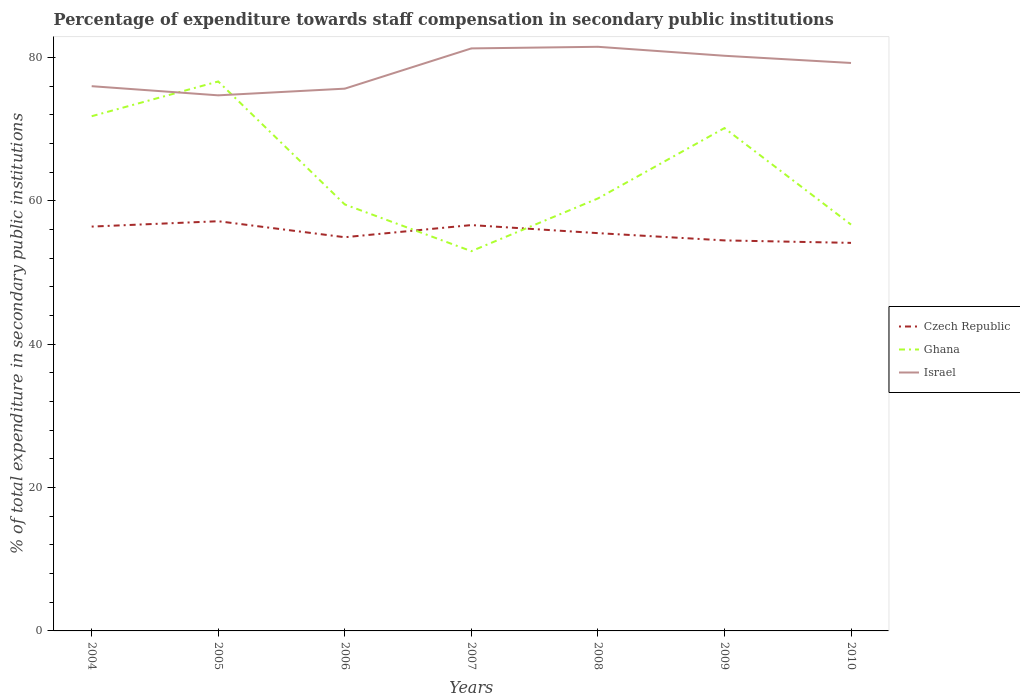How many different coloured lines are there?
Give a very brief answer. 3. Does the line corresponding to Israel intersect with the line corresponding to Czech Republic?
Provide a short and direct response. No. Is the number of lines equal to the number of legend labels?
Keep it short and to the point. Yes. Across all years, what is the maximum percentage of expenditure towards staff compensation in Israel?
Provide a succinct answer. 74.7. What is the total percentage of expenditure towards staff compensation in Czech Republic in the graph?
Provide a succinct answer. 2.27. What is the difference between the highest and the second highest percentage of expenditure towards staff compensation in Israel?
Your response must be concise. 6.77. What is the difference between the highest and the lowest percentage of expenditure towards staff compensation in Czech Republic?
Keep it short and to the point. 3. Is the percentage of expenditure towards staff compensation in Israel strictly greater than the percentage of expenditure towards staff compensation in Czech Republic over the years?
Offer a very short reply. No. Does the graph contain grids?
Your answer should be very brief. No. Where does the legend appear in the graph?
Give a very brief answer. Center right. How many legend labels are there?
Keep it short and to the point. 3. How are the legend labels stacked?
Make the answer very short. Vertical. What is the title of the graph?
Provide a succinct answer. Percentage of expenditure towards staff compensation in secondary public institutions. Does "Tonga" appear as one of the legend labels in the graph?
Your answer should be compact. No. What is the label or title of the X-axis?
Make the answer very short. Years. What is the label or title of the Y-axis?
Give a very brief answer. % of total expenditure in secondary public institutions. What is the % of total expenditure in secondary public institutions of Czech Republic in 2004?
Give a very brief answer. 56.39. What is the % of total expenditure in secondary public institutions in Ghana in 2004?
Offer a very short reply. 71.79. What is the % of total expenditure in secondary public institutions of Israel in 2004?
Your answer should be compact. 75.97. What is the % of total expenditure in secondary public institutions in Czech Republic in 2005?
Your answer should be compact. 57.14. What is the % of total expenditure in secondary public institutions in Ghana in 2005?
Make the answer very short. 76.63. What is the % of total expenditure in secondary public institutions of Israel in 2005?
Offer a terse response. 74.7. What is the % of total expenditure in secondary public institutions in Czech Republic in 2006?
Offer a very short reply. 54.91. What is the % of total expenditure in secondary public institutions of Ghana in 2006?
Your answer should be compact. 59.48. What is the % of total expenditure in secondary public institutions in Israel in 2006?
Provide a succinct answer. 75.63. What is the % of total expenditure in secondary public institutions in Czech Republic in 2007?
Give a very brief answer. 56.6. What is the % of total expenditure in secondary public institutions in Ghana in 2007?
Offer a very short reply. 52.97. What is the % of total expenditure in secondary public institutions in Israel in 2007?
Give a very brief answer. 81.24. What is the % of total expenditure in secondary public institutions of Czech Republic in 2008?
Your answer should be compact. 55.48. What is the % of total expenditure in secondary public institutions of Ghana in 2008?
Your answer should be compact. 60.31. What is the % of total expenditure in secondary public institutions in Israel in 2008?
Offer a very short reply. 81.47. What is the % of total expenditure in secondary public institutions in Czech Republic in 2009?
Your answer should be very brief. 54.46. What is the % of total expenditure in secondary public institutions in Ghana in 2009?
Give a very brief answer. 70.13. What is the % of total expenditure in secondary public institutions of Israel in 2009?
Your answer should be very brief. 80.22. What is the % of total expenditure in secondary public institutions of Czech Republic in 2010?
Offer a terse response. 54.12. What is the % of total expenditure in secondary public institutions in Ghana in 2010?
Make the answer very short. 56.67. What is the % of total expenditure in secondary public institutions in Israel in 2010?
Your answer should be compact. 79.21. Across all years, what is the maximum % of total expenditure in secondary public institutions in Czech Republic?
Your response must be concise. 57.14. Across all years, what is the maximum % of total expenditure in secondary public institutions of Ghana?
Provide a short and direct response. 76.63. Across all years, what is the maximum % of total expenditure in secondary public institutions in Israel?
Provide a succinct answer. 81.47. Across all years, what is the minimum % of total expenditure in secondary public institutions of Czech Republic?
Ensure brevity in your answer.  54.12. Across all years, what is the minimum % of total expenditure in secondary public institutions of Ghana?
Provide a short and direct response. 52.97. Across all years, what is the minimum % of total expenditure in secondary public institutions in Israel?
Your answer should be compact. 74.7. What is the total % of total expenditure in secondary public institutions of Czech Republic in the graph?
Make the answer very short. 389.11. What is the total % of total expenditure in secondary public institutions in Ghana in the graph?
Your answer should be very brief. 447.98. What is the total % of total expenditure in secondary public institutions of Israel in the graph?
Provide a short and direct response. 548.44. What is the difference between the % of total expenditure in secondary public institutions in Czech Republic in 2004 and that in 2005?
Your answer should be very brief. -0.75. What is the difference between the % of total expenditure in secondary public institutions of Ghana in 2004 and that in 2005?
Keep it short and to the point. -4.85. What is the difference between the % of total expenditure in secondary public institutions of Israel in 2004 and that in 2005?
Ensure brevity in your answer.  1.28. What is the difference between the % of total expenditure in secondary public institutions of Czech Republic in 2004 and that in 2006?
Make the answer very short. 1.48. What is the difference between the % of total expenditure in secondary public institutions in Ghana in 2004 and that in 2006?
Give a very brief answer. 12.31. What is the difference between the % of total expenditure in secondary public institutions of Israel in 2004 and that in 2006?
Give a very brief answer. 0.35. What is the difference between the % of total expenditure in secondary public institutions of Czech Republic in 2004 and that in 2007?
Ensure brevity in your answer.  -0.21. What is the difference between the % of total expenditure in secondary public institutions of Ghana in 2004 and that in 2007?
Ensure brevity in your answer.  18.82. What is the difference between the % of total expenditure in secondary public institutions in Israel in 2004 and that in 2007?
Offer a very short reply. -5.27. What is the difference between the % of total expenditure in secondary public institutions in Czech Republic in 2004 and that in 2008?
Give a very brief answer. 0.91. What is the difference between the % of total expenditure in secondary public institutions of Ghana in 2004 and that in 2008?
Your response must be concise. 11.47. What is the difference between the % of total expenditure in secondary public institutions in Israel in 2004 and that in 2008?
Offer a terse response. -5.49. What is the difference between the % of total expenditure in secondary public institutions of Czech Republic in 2004 and that in 2009?
Make the answer very short. 1.93. What is the difference between the % of total expenditure in secondary public institutions in Ghana in 2004 and that in 2009?
Offer a terse response. 1.65. What is the difference between the % of total expenditure in secondary public institutions of Israel in 2004 and that in 2009?
Provide a succinct answer. -4.24. What is the difference between the % of total expenditure in secondary public institutions of Czech Republic in 2004 and that in 2010?
Give a very brief answer. 2.27. What is the difference between the % of total expenditure in secondary public institutions in Ghana in 2004 and that in 2010?
Ensure brevity in your answer.  15.11. What is the difference between the % of total expenditure in secondary public institutions in Israel in 2004 and that in 2010?
Provide a short and direct response. -3.24. What is the difference between the % of total expenditure in secondary public institutions of Czech Republic in 2005 and that in 2006?
Offer a very short reply. 2.23. What is the difference between the % of total expenditure in secondary public institutions in Ghana in 2005 and that in 2006?
Provide a succinct answer. 17.16. What is the difference between the % of total expenditure in secondary public institutions of Israel in 2005 and that in 2006?
Provide a succinct answer. -0.93. What is the difference between the % of total expenditure in secondary public institutions in Czech Republic in 2005 and that in 2007?
Your response must be concise. 0.54. What is the difference between the % of total expenditure in secondary public institutions in Ghana in 2005 and that in 2007?
Your answer should be compact. 23.67. What is the difference between the % of total expenditure in secondary public institutions of Israel in 2005 and that in 2007?
Your answer should be compact. -6.54. What is the difference between the % of total expenditure in secondary public institutions of Czech Republic in 2005 and that in 2008?
Provide a succinct answer. 1.66. What is the difference between the % of total expenditure in secondary public institutions of Ghana in 2005 and that in 2008?
Provide a succinct answer. 16.32. What is the difference between the % of total expenditure in secondary public institutions in Israel in 2005 and that in 2008?
Offer a terse response. -6.77. What is the difference between the % of total expenditure in secondary public institutions in Czech Republic in 2005 and that in 2009?
Keep it short and to the point. 2.68. What is the difference between the % of total expenditure in secondary public institutions in Ghana in 2005 and that in 2009?
Make the answer very short. 6.5. What is the difference between the % of total expenditure in secondary public institutions of Israel in 2005 and that in 2009?
Ensure brevity in your answer.  -5.52. What is the difference between the % of total expenditure in secondary public institutions in Czech Republic in 2005 and that in 2010?
Make the answer very short. 3.02. What is the difference between the % of total expenditure in secondary public institutions of Ghana in 2005 and that in 2010?
Your response must be concise. 19.96. What is the difference between the % of total expenditure in secondary public institutions of Israel in 2005 and that in 2010?
Your response must be concise. -4.51. What is the difference between the % of total expenditure in secondary public institutions of Czech Republic in 2006 and that in 2007?
Your answer should be compact. -1.69. What is the difference between the % of total expenditure in secondary public institutions in Ghana in 2006 and that in 2007?
Keep it short and to the point. 6.51. What is the difference between the % of total expenditure in secondary public institutions of Israel in 2006 and that in 2007?
Offer a very short reply. -5.61. What is the difference between the % of total expenditure in secondary public institutions of Czech Republic in 2006 and that in 2008?
Your answer should be very brief. -0.57. What is the difference between the % of total expenditure in secondary public institutions of Ghana in 2006 and that in 2008?
Your response must be concise. -0.84. What is the difference between the % of total expenditure in secondary public institutions of Israel in 2006 and that in 2008?
Offer a terse response. -5.84. What is the difference between the % of total expenditure in secondary public institutions of Czech Republic in 2006 and that in 2009?
Give a very brief answer. 0.44. What is the difference between the % of total expenditure in secondary public institutions of Ghana in 2006 and that in 2009?
Offer a terse response. -10.65. What is the difference between the % of total expenditure in secondary public institutions in Israel in 2006 and that in 2009?
Keep it short and to the point. -4.59. What is the difference between the % of total expenditure in secondary public institutions in Czech Republic in 2006 and that in 2010?
Offer a very short reply. 0.79. What is the difference between the % of total expenditure in secondary public institutions in Ghana in 2006 and that in 2010?
Your answer should be compact. 2.81. What is the difference between the % of total expenditure in secondary public institutions in Israel in 2006 and that in 2010?
Your answer should be very brief. -3.58. What is the difference between the % of total expenditure in secondary public institutions in Czech Republic in 2007 and that in 2008?
Offer a very short reply. 1.12. What is the difference between the % of total expenditure in secondary public institutions in Ghana in 2007 and that in 2008?
Offer a very short reply. -7.35. What is the difference between the % of total expenditure in secondary public institutions in Israel in 2007 and that in 2008?
Make the answer very short. -0.23. What is the difference between the % of total expenditure in secondary public institutions in Czech Republic in 2007 and that in 2009?
Your response must be concise. 2.14. What is the difference between the % of total expenditure in secondary public institutions of Ghana in 2007 and that in 2009?
Your answer should be very brief. -17.17. What is the difference between the % of total expenditure in secondary public institutions of Israel in 2007 and that in 2009?
Keep it short and to the point. 1.03. What is the difference between the % of total expenditure in secondary public institutions in Czech Republic in 2007 and that in 2010?
Provide a short and direct response. 2.48. What is the difference between the % of total expenditure in secondary public institutions in Ghana in 2007 and that in 2010?
Your answer should be compact. -3.71. What is the difference between the % of total expenditure in secondary public institutions of Israel in 2007 and that in 2010?
Make the answer very short. 2.03. What is the difference between the % of total expenditure in secondary public institutions of Czech Republic in 2008 and that in 2009?
Make the answer very short. 1.01. What is the difference between the % of total expenditure in secondary public institutions of Ghana in 2008 and that in 2009?
Provide a short and direct response. -9.82. What is the difference between the % of total expenditure in secondary public institutions in Israel in 2008 and that in 2009?
Provide a short and direct response. 1.25. What is the difference between the % of total expenditure in secondary public institutions in Czech Republic in 2008 and that in 2010?
Your response must be concise. 1.36. What is the difference between the % of total expenditure in secondary public institutions of Ghana in 2008 and that in 2010?
Make the answer very short. 3.64. What is the difference between the % of total expenditure in secondary public institutions in Israel in 2008 and that in 2010?
Ensure brevity in your answer.  2.26. What is the difference between the % of total expenditure in secondary public institutions of Czech Republic in 2009 and that in 2010?
Your response must be concise. 0.34. What is the difference between the % of total expenditure in secondary public institutions in Ghana in 2009 and that in 2010?
Make the answer very short. 13.46. What is the difference between the % of total expenditure in secondary public institutions of Czech Republic in 2004 and the % of total expenditure in secondary public institutions of Ghana in 2005?
Offer a very short reply. -20.24. What is the difference between the % of total expenditure in secondary public institutions in Czech Republic in 2004 and the % of total expenditure in secondary public institutions in Israel in 2005?
Ensure brevity in your answer.  -18.31. What is the difference between the % of total expenditure in secondary public institutions in Ghana in 2004 and the % of total expenditure in secondary public institutions in Israel in 2005?
Offer a terse response. -2.91. What is the difference between the % of total expenditure in secondary public institutions in Czech Republic in 2004 and the % of total expenditure in secondary public institutions in Ghana in 2006?
Offer a very short reply. -3.08. What is the difference between the % of total expenditure in secondary public institutions in Czech Republic in 2004 and the % of total expenditure in secondary public institutions in Israel in 2006?
Your answer should be compact. -19.24. What is the difference between the % of total expenditure in secondary public institutions of Ghana in 2004 and the % of total expenditure in secondary public institutions of Israel in 2006?
Give a very brief answer. -3.84. What is the difference between the % of total expenditure in secondary public institutions in Czech Republic in 2004 and the % of total expenditure in secondary public institutions in Ghana in 2007?
Your answer should be compact. 3.43. What is the difference between the % of total expenditure in secondary public institutions of Czech Republic in 2004 and the % of total expenditure in secondary public institutions of Israel in 2007?
Offer a very short reply. -24.85. What is the difference between the % of total expenditure in secondary public institutions of Ghana in 2004 and the % of total expenditure in secondary public institutions of Israel in 2007?
Give a very brief answer. -9.46. What is the difference between the % of total expenditure in secondary public institutions of Czech Republic in 2004 and the % of total expenditure in secondary public institutions of Ghana in 2008?
Ensure brevity in your answer.  -3.92. What is the difference between the % of total expenditure in secondary public institutions in Czech Republic in 2004 and the % of total expenditure in secondary public institutions in Israel in 2008?
Make the answer very short. -25.08. What is the difference between the % of total expenditure in secondary public institutions in Ghana in 2004 and the % of total expenditure in secondary public institutions in Israel in 2008?
Offer a terse response. -9.68. What is the difference between the % of total expenditure in secondary public institutions of Czech Republic in 2004 and the % of total expenditure in secondary public institutions of Ghana in 2009?
Offer a terse response. -13.74. What is the difference between the % of total expenditure in secondary public institutions of Czech Republic in 2004 and the % of total expenditure in secondary public institutions of Israel in 2009?
Keep it short and to the point. -23.82. What is the difference between the % of total expenditure in secondary public institutions in Ghana in 2004 and the % of total expenditure in secondary public institutions in Israel in 2009?
Provide a short and direct response. -8.43. What is the difference between the % of total expenditure in secondary public institutions of Czech Republic in 2004 and the % of total expenditure in secondary public institutions of Ghana in 2010?
Your answer should be very brief. -0.28. What is the difference between the % of total expenditure in secondary public institutions in Czech Republic in 2004 and the % of total expenditure in secondary public institutions in Israel in 2010?
Ensure brevity in your answer.  -22.82. What is the difference between the % of total expenditure in secondary public institutions in Ghana in 2004 and the % of total expenditure in secondary public institutions in Israel in 2010?
Provide a succinct answer. -7.43. What is the difference between the % of total expenditure in secondary public institutions of Czech Republic in 2005 and the % of total expenditure in secondary public institutions of Ghana in 2006?
Provide a succinct answer. -2.34. What is the difference between the % of total expenditure in secondary public institutions in Czech Republic in 2005 and the % of total expenditure in secondary public institutions in Israel in 2006?
Offer a terse response. -18.49. What is the difference between the % of total expenditure in secondary public institutions of Czech Republic in 2005 and the % of total expenditure in secondary public institutions of Ghana in 2007?
Offer a very short reply. 4.18. What is the difference between the % of total expenditure in secondary public institutions of Czech Republic in 2005 and the % of total expenditure in secondary public institutions of Israel in 2007?
Your answer should be very brief. -24.1. What is the difference between the % of total expenditure in secondary public institutions of Ghana in 2005 and the % of total expenditure in secondary public institutions of Israel in 2007?
Offer a terse response. -4.61. What is the difference between the % of total expenditure in secondary public institutions of Czech Republic in 2005 and the % of total expenditure in secondary public institutions of Ghana in 2008?
Your answer should be very brief. -3.17. What is the difference between the % of total expenditure in secondary public institutions in Czech Republic in 2005 and the % of total expenditure in secondary public institutions in Israel in 2008?
Keep it short and to the point. -24.33. What is the difference between the % of total expenditure in secondary public institutions of Ghana in 2005 and the % of total expenditure in secondary public institutions of Israel in 2008?
Your answer should be very brief. -4.84. What is the difference between the % of total expenditure in secondary public institutions in Czech Republic in 2005 and the % of total expenditure in secondary public institutions in Ghana in 2009?
Offer a terse response. -12.99. What is the difference between the % of total expenditure in secondary public institutions in Czech Republic in 2005 and the % of total expenditure in secondary public institutions in Israel in 2009?
Provide a short and direct response. -23.08. What is the difference between the % of total expenditure in secondary public institutions of Ghana in 2005 and the % of total expenditure in secondary public institutions of Israel in 2009?
Ensure brevity in your answer.  -3.58. What is the difference between the % of total expenditure in secondary public institutions of Czech Republic in 2005 and the % of total expenditure in secondary public institutions of Ghana in 2010?
Keep it short and to the point. 0.47. What is the difference between the % of total expenditure in secondary public institutions in Czech Republic in 2005 and the % of total expenditure in secondary public institutions in Israel in 2010?
Your answer should be very brief. -22.07. What is the difference between the % of total expenditure in secondary public institutions in Ghana in 2005 and the % of total expenditure in secondary public institutions in Israel in 2010?
Offer a terse response. -2.58. What is the difference between the % of total expenditure in secondary public institutions in Czech Republic in 2006 and the % of total expenditure in secondary public institutions in Ghana in 2007?
Give a very brief answer. 1.94. What is the difference between the % of total expenditure in secondary public institutions of Czech Republic in 2006 and the % of total expenditure in secondary public institutions of Israel in 2007?
Provide a short and direct response. -26.33. What is the difference between the % of total expenditure in secondary public institutions in Ghana in 2006 and the % of total expenditure in secondary public institutions in Israel in 2007?
Ensure brevity in your answer.  -21.77. What is the difference between the % of total expenditure in secondary public institutions in Czech Republic in 2006 and the % of total expenditure in secondary public institutions in Ghana in 2008?
Ensure brevity in your answer.  -5.4. What is the difference between the % of total expenditure in secondary public institutions in Czech Republic in 2006 and the % of total expenditure in secondary public institutions in Israel in 2008?
Your answer should be compact. -26.56. What is the difference between the % of total expenditure in secondary public institutions of Ghana in 2006 and the % of total expenditure in secondary public institutions of Israel in 2008?
Make the answer very short. -21.99. What is the difference between the % of total expenditure in secondary public institutions in Czech Republic in 2006 and the % of total expenditure in secondary public institutions in Ghana in 2009?
Provide a short and direct response. -15.22. What is the difference between the % of total expenditure in secondary public institutions in Czech Republic in 2006 and the % of total expenditure in secondary public institutions in Israel in 2009?
Offer a very short reply. -25.31. What is the difference between the % of total expenditure in secondary public institutions of Ghana in 2006 and the % of total expenditure in secondary public institutions of Israel in 2009?
Offer a very short reply. -20.74. What is the difference between the % of total expenditure in secondary public institutions of Czech Republic in 2006 and the % of total expenditure in secondary public institutions of Ghana in 2010?
Give a very brief answer. -1.76. What is the difference between the % of total expenditure in secondary public institutions in Czech Republic in 2006 and the % of total expenditure in secondary public institutions in Israel in 2010?
Offer a very short reply. -24.3. What is the difference between the % of total expenditure in secondary public institutions in Ghana in 2006 and the % of total expenditure in secondary public institutions in Israel in 2010?
Make the answer very short. -19.73. What is the difference between the % of total expenditure in secondary public institutions of Czech Republic in 2007 and the % of total expenditure in secondary public institutions of Ghana in 2008?
Make the answer very short. -3.71. What is the difference between the % of total expenditure in secondary public institutions in Czech Republic in 2007 and the % of total expenditure in secondary public institutions in Israel in 2008?
Your answer should be compact. -24.87. What is the difference between the % of total expenditure in secondary public institutions of Ghana in 2007 and the % of total expenditure in secondary public institutions of Israel in 2008?
Provide a succinct answer. -28.5. What is the difference between the % of total expenditure in secondary public institutions of Czech Republic in 2007 and the % of total expenditure in secondary public institutions of Ghana in 2009?
Offer a very short reply. -13.53. What is the difference between the % of total expenditure in secondary public institutions of Czech Republic in 2007 and the % of total expenditure in secondary public institutions of Israel in 2009?
Keep it short and to the point. -23.62. What is the difference between the % of total expenditure in secondary public institutions in Ghana in 2007 and the % of total expenditure in secondary public institutions in Israel in 2009?
Your response must be concise. -27.25. What is the difference between the % of total expenditure in secondary public institutions of Czech Republic in 2007 and the % of total expenditure in secondary public institutions of Ghana in 2010?
Your response must be concise. -0.07. What is the difference between the % of total expenditure in secondary public institutions in Czech Republic in 2007 and the % of total expenditure in secondary public institutions in Israel in 2010?
Your response must be concise. -22.61. What is the difference between the % of total expenditure in secondary public institutions in Ghana in 2007 and the % of total expenditure in secondary public institutions in Israel in 2010?
Ensure brevity in your answer.  -26.25. What is the difference between the % of total expenditure in secondary public institutions of Czech Republic in 2008 and the % of total expenditure in secondary public institutions of Ghana in 2009?
Provide a short and direct response. -14.65. What is the difference between the % of total expenditure in secondary public institutions of Czech Republic in 2008 and the % of total expenditure in secondary public institutions of Israel in 2009?
Your answer should be compact. -24.74. What is the difference between the % of total expenditure in secondary public institutions of Ghana in 2008 and the % of total expenditure in secondary public institutions of Israel in 2009?
Offer a terse response. -19.9. What is the difference between the % of total expenditure in secondary public institutions of Czech Republic in 2008 and the % of total expenditure in secondary public institutions of Ghana in 2010?
Ensure brevity in your answer.  -1.19. What is the difference between the % of total expenditure in secondary public institutions of Czech Republic in 2008 and the % of total expenditure in secondary public institutions of Israel in 2010?
Keep it short and to the point. -23.73. What is the difference between the % of total expenditure in secondary public institutions in Ghana in 2008 and the % of total expenditure in secondary public institutions in Israel in 2010?
Ensure brevity in your answer.  -18.9. What is the difference between the % of total expenditure in secondary public institutions in Czech Republic in 2009 and the % of total expenditure in secondary public institutions in Ghana in 2010?
Your response must be concise. -2.21. What is the difference between the % of total expenditure in secondary public institutions in Czech Republic in 2009 and the % of total expenditure in secondary public institutions in Israel in 2010?
Keep it short and to the point. -24.75. What is the difference between the % of total expenditure in secondary public institutions in Ghana in 2009 and the % of total expenditure in secondary public institutions in Israel in 2010?
Your answer should be very brief. -9.08. What is the average % of total expenditure in secondary public institutions of Czech Republic per year?
Provide a succinct answer. 55.59. What is the average % of total expenditure in secondary public institutions in Ghana per year?
Provide a short and direct response. 64. What is the average % of total expenditure in secondary public institutions in Israel per year?
Your answer should be very brief. 78.35. In the year 2004, what is the difference between the % of total expenditure in secondary public institutions in Czech Republic and % of total expenditure in secondary public institutions in Ghana?
Offer a very short reply. -15.39. In the year 2004, what is the difference between the % of total expenditure in secondary public institutions in Czech Republic and % of total expenditure in secondary public institutions in Israel?
Provide a succinct answer. -19.58. In the year 2004, what is the difference between the % of total expenditure in secondary public institutions of Ghana and % of total expenditure in secondary public institutions of Israel?
Ensure brevity in your answer.  -4.19. In the year 2005, what is the difference between the % of total expenditure in secondary public institutions of Czech Republic and % of total expenditure in secondary public institutions of Ghana?
Your response must be concise. -19.49. In the year 2005, what is the difference between the % of total expenditure in secondary public institutions of Czech Republic and % of total expenditure in secondary public institutions of Israel?
Give a very brief answer. -17.56. In the year 2005, what is the difference between the % of total expenditure in secondary public institutions in Ghana and % of total expenditure in secondary public institutions in Israel?
Your answer should be very brief. 1.93. In the year 2006, what is the difference between the % of total expenditure in secondary public institutions of Czech Republic and % of total expenditure in secondary public institutions of Ghana?
Ensure brevity in your answer.  -4.57. In the year 2006, what is the difference between the % of total expenditure in secondary public institutions of Czech Republic and % of total expenditure in secondary public institutions of Israel?
Provide a succinct answer. -20.72. In the year 2006, what is the difference between the % of total expenditure in secondary public institutions of Ghana and % of total expenditure in secondary public institutions of Israel?
Provide a short and direct response. -16.15. In the year 2007, what is the difference between the % of total expenditure in secondary public institutions in Czech Republic and % of total expenditure in secondary public institutions in Ghana?
Your answer should be very brief. 3.64. In the year 2007, what is the difference between the % of total expenditure in secondary public institutions of Czech Republic and % of total expenditure in secondary public institutions of Israel?
Offer a very short reply. -24.64. In the year 2007, what is the difference between the % of total expenditure in secondary public institutions of Ghana and % of total expenditure in secondary public institutions of Israel?
Ensure brevity in your answer.  -28.28. In the year 2008, what is the difference between the % of total expenditure in secondary public institutions of Czech Republic and % of total expenditure in secondary public institutions of Ghana?
Offer a very short reply. -4.83. In the year 2008, what is the difference between the % of total expenditure in secondary public institutions of Czech Republic and % of total expenditure in secondary public institutions of Israel?
Offer a very short reply. -25.99. In the year 2008, what is the difference between the % of total expenditure in secondary public institutions of Ghana and % of total expenditure in secondary public institutions of Israel?
Keep it short and to the point. -21.15. In the year 2009, what is the difference between the % of total expenditure in secondary public institutions in Czech Republic and % of total expenditure in secondary public institutions in Ghana?
Give a very brief answer. -15.67. In the year 2009, what is the difference between the % of total expenditure in secondary public institutions in Czech Republic and % of total expenditure in secondary public institutions in Israel?
Offer a very short reply. -25.75. In the year 2009, what is the difference between the % of total expenditure in secondary public institutions in Ghana and % of total expenditure in secondary public institutions in Israel?
Keep it short and to the point. -10.09. In the year 2010, what is the difference between the % of total expenditure in secondary public institutions in Czech Republic and % of total expenditure in secondary public institutions in Ghana?
Offer a very short reply. -2.55. In the year 2010, what is the difference between the % of total expenditure in secondary public institutions in Czech Republic and % of total expenditure in secondary public institutions in Israel?
Make the answer very short. -25.09. In the year 2010, what is the difference between the % of total expenditure in secondary public institutions of Ghana and % of total expenditure in secondary public institutions of Israel?
Offer a terse response. -22.54. What is the ratio of the % of total expenditure in secondary public institutions of Czech Republic in 2004 to that in 2005?
Offer a very short reply. 0.99. What is the ratio of the % of total expenditure in secondary public institutions in Ghana in 2004 to that in 2005?
Offer a very short reply. 0.94. What is the ratio of the % of total expenditure in secondary public institutions of Israel in 2004 to that in 2005?
Ensure brevity in your answer.  1.02. What is the ratio of the % of total expenditure in secondary public institutions in Czech Republic in 2004 to that in 2006?
Your response must be concise. 1.03. What is the ratio of the % of total expenditure in secondary public institutions in Ghana in 2004 to that in 2006?
Provide a short and direct response. 1.21. What is the ratio of the % of total expenditure in secondary public institutions of Ghana in 2004 to that in 2007?
Offer a terse response. 1.36. What is the ratio of the % of total expenditure in secondary public institutions in Israel in 2004 to that in 2007?
Make the answer very short. 0.94. What is the ratio of the % of total expenditure in secondary public institutions of Czech Republic in 2004 to that in 2008?
Give a very brief answer. 1.02. What is the ratio of the % of total expenditure in secondary public institutions of Ghana in 2004 to that in 2008?
Your response must be concise. 1.19. What is the ratio of the % of total expenditure in secondary public institutions in Israel in 2004 to that in 2008?
Offer a very short reply. 0.93. What is the ratio of the % of total expenditure in secondary public institutions in Czech Republic in 2004 to that in 2009?
Your response must be concise. 1.04. What is the ratio of the % of total expenditure in secondary public institutions in Ghana in 2004 to that in 2009?
Your answer should be very brief. 1.02. What is the ratio of the % of total expenditure in secondary public institutions of Israel in 2004 to that in 2009?
Offer a terse response. 0.95. What is the ratio of the % of total expenditure in secondary public institutions of Czech Republic in 2004 to that in 2010?
Keep it short and to the point. 1.04. What is the ratio of the % of total expenditure in secondary public institutions of Ghana in 2004 to that in 2010?
Make the answer very short. 1.27. What is the ratio of the % of total expenditure in secondary public institutions of Israel in 2004 to that in 2010?
Provide a short and direct response. 0.96. What is the ratio of the % of total expenditure in secondary public institutions in Czech Republic in 2005 to that in 2006?
Offer a very short reply. 1.04. What is the ratio of the % of total expenditure in secondary public institutions of Ghana in 2005 to that in 2006?
Provide a short and direct response. 1.29. What is the ratio of the % of total expenditure in secondary public institutions of Israel in 2005 to that in 2006?
Make the answer very short. 0.99. What is the ratio of the % of total expenditure in secondary public institutions of Czech Republic in 2005 to that in 2007?
Your response must be concise. 1.01. What is the ratio of the % of total expenditure in secondary public institutions in Ghana in 2005 to that in 2007?
Give a very brief answer. 1.45. What is the ratio of the % of total expenditure in secondary public institutions in Israel in 2005 to that in 2007?
Make the answer very short. 0.92. What is the ratio of the % of total expenditure in secondary public institutions in Czech Republic in 2005 to that in 2008?
Provide a short and direct response. 1.03. What is the ratio of the % of total expenditure in secondary public institutions in Ghana in 2005 to that in 2008?
Your answer should be very brief. 1.27. What is the ratio of the % of total expenditure in secondary public institutions of Israel in 2005 to that in 2008?
Keep it short and to the point. 0.92. What is the ratio of the % of total expenditure in secondary public institutions of Czech Republic in 2005 to that in 2009?
Provide a short and direct response. 1.05. What is the ratio of the % of total expenditure in secondary public institutions of Ghana in 2005 to that in 2009?
Give a very brief answer. 1.09. What is the ratio of the % of total expenditure in secondary public institutions of Israel in 2005 to that in 2009?
Your answer should be very brief. 0.93. What is the ratio of the % of total expenditure in secondary public institutions of Czech Republic in 2005 to that in 2010?
Provide a succinct answer. 1.06. What is the ratio of the % of total expenditure in secondary public institutions in Ghana in 2005 to that in 2010?
Give a very brief answer. 1.35. What is the ratio of the % of total expenditure in secondary public institutions in Israel in 2005 to that in 2010?
Provide a short and direct response. 0.94. What is the ratio of the % of total expenditure in secondary public institutions in Czech Republic in 2006 to that in 2007?
Offer a very short reply. 0.97. What is the ratio of the % of total expenditure in secondary public institutions of Ghana in 2006 to that in 2007?
Your answer should be compact. 1.12. What is the ratio of the % of total expenditure in secondary public institutions in Israel in 2006 to that in 2007?
Your answer should be very brief. 0.93. What is the ratio of the % of total expenditure in secondary public institutions in Czech Republic in 2006 to that in 2008?
Provide a short and direct response. 0.99. What is the ratio of the % of total expenditure in secondary public institutions in Ghana in 2006 to that in 2008?
Offer a terse response. 0.99. What is the ratio of the % of total expenditure in secondary public institutions of Israel in 2006 to that in 2008?
Ensure brevity in your answer.  0.93. What is the ratio of the % of total expenditure in secondary public institutions in Czech Republic in 2006 to that in 2009?
Offer a very short reply. 1.01. What is the ratio of the % of total expenditure in secondary public institutions of Ghana in 2006 to that in 2009?
Offer a terse response. 0.85. What is the ratio of the % of total expenditure in secondary public institutions in Israel in 2006 to that in 2009?
Your answer should be very brief. 0.94. What is the ratio of the % of total expenditure in secondary public institutions of Czech Republic in 2006 to that in 2010?
Give a very brief answer. 1.01. What is the ratio of the % of total expenditure in secondary public institutions in Ghana in 2006 to that in 2010?
Make the answer very short. 1.05. What is the ratio of the % of total expenditure in secondary public institutions in Israel in 2006 to that in 2010?
Keep it short and to the point. 0.95. What is the ratio of the % of total expenditure in secondary public institutions in Czech Republic in 2007 to that in 2008?
Offer a very short reply. 1.02. What is the ratio of the % of total expenditure in secondary public institutions in Ghana in 2007 to that in 2008?
Your answer should be compact. 0.88. What is the ratio of the % of total expenditure in secondary public institutions in Czech Republic in 2007 to that in 2009?
Your response must be concise. 1.04. What is the ratio of the % of total expenditure in secondary public institutions in Ghana in 2007 to that in 2009?
Offer a terse response. 0.76. What is the ratio of the % of total expenditure in secondary public institutions of Israel in 2007 to that in 2009?
Offer a terse response. 1.01. What is the ratio of the % of total expenditure in secondary public institutions of Czech Republic in 2007 to that in 2010?
Offer a very short reply. 1.05. What is the ratio of the % of total expenditure in secondary public institutions in Ghana in 2007 to that in 2010?
Provide a short and direct response. 0.93. What is the ratio of the % of total expenditure in secondary public institutions of Israel in 2007 to that in 2010?
Provide a succinct answer. 1.03. What is the ratio of the % of total expenditure in secondary public institutions in Czech Republic in 2008 to that in 2009?
Give a very brief answer. 1.02. What is the ratio of the % of total expenditure in secondary public institutions in Ghana in 2008 to that in 2009?
Offer a very short reply. 0.86. What is the ratio of the % of total expenditure in secondary public institutions in Israel in 2008 to that in 2009?
Your response must be concise. 1.02. What is the ratio of the % of total expenditure in secondary public institutions of Czech Republic in 2008 to that in 2010?
Provide a short and direct response. 1.03. What is the ratio of the % of total expenditure in secondary public institutions of Ghana in 2008 to that in 2010?
Offer a terse response. 1.06. What is the ratio of the % of total expenditure in secondary public institutions of Israel in 2008 to that in 2010?
Offer a terse response. 1.03. What is the ratio of the % of total expenditure in secondary public institutions of Czech Republic in 2009 to that in 2010?
Offer a very short reply. 1.01. What is the ratio of the % of total expenditure in secondary public institutions of Ghana in 2009 to that in 2010?
Provide a short and direct response. 1.24. What is the ratio of the % of total expenditure in secondary public institutions in Israel in 2009 to that in 2010?
Offer a very short reply. 1.01. What is the difference between the highest and the second highest % of total expenditure in secondary public institutions in Czech Republic?
Your response must be concise. 0.54. What is the difference between the highest and the second highest % of total expenditure in secondary public institutions of Ghana?
Ensure brevity in your answer.  4.85. What is the difference between the highest and the second highest % of total expenditure in secondary public institutions of Israel?
Offer a very short reply. 0.23. What is the difference between the highest and the lowest % of total expenditure in secondary public institutions of Czech Republic?
Offer a very short reply. 3.02. What is the difference between the highest and the lowest % of total expenditure in secondary public institutions of Ghana?
Offer a terse response. 23.67. What is the difference between the highest and the lowest % of total expenditure in secondary public institutions of Israel?
Your answer should be compact. 6.77. 